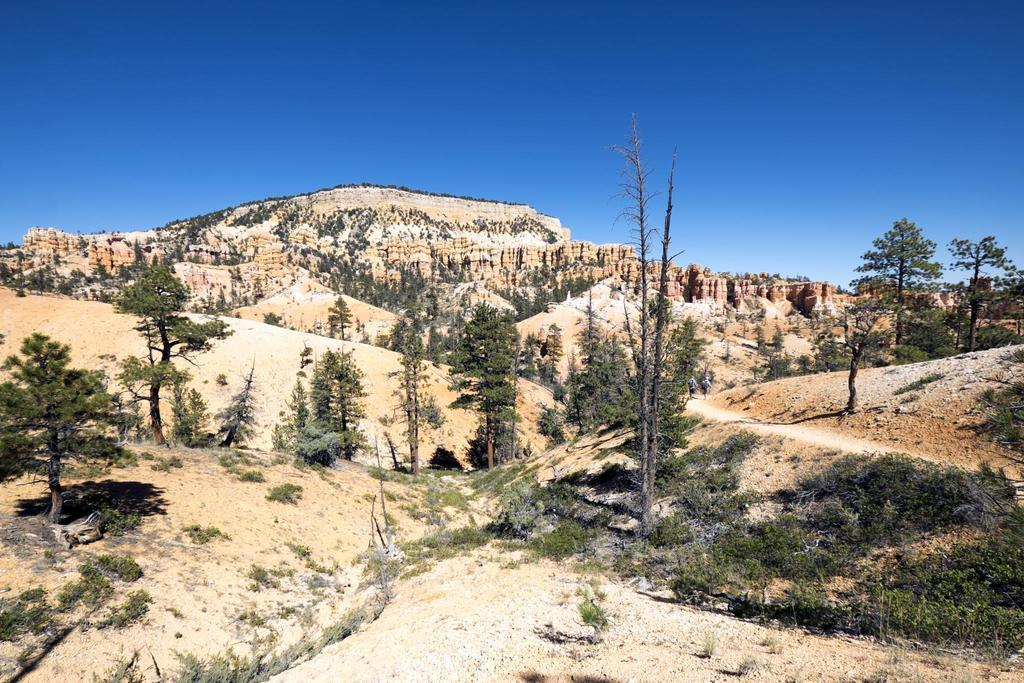What is the setting of the image? The image is set in a desert. What type of vegetation can be seen in the desert? There are many trees in the desert. What type of string can be seen tied around the trees in the image? There is no string tied around the trees in the image; only trees are visible in the desert. What type of garden can be seen in the image? There is no garden present in the image; it is set in a desert with many trees. 